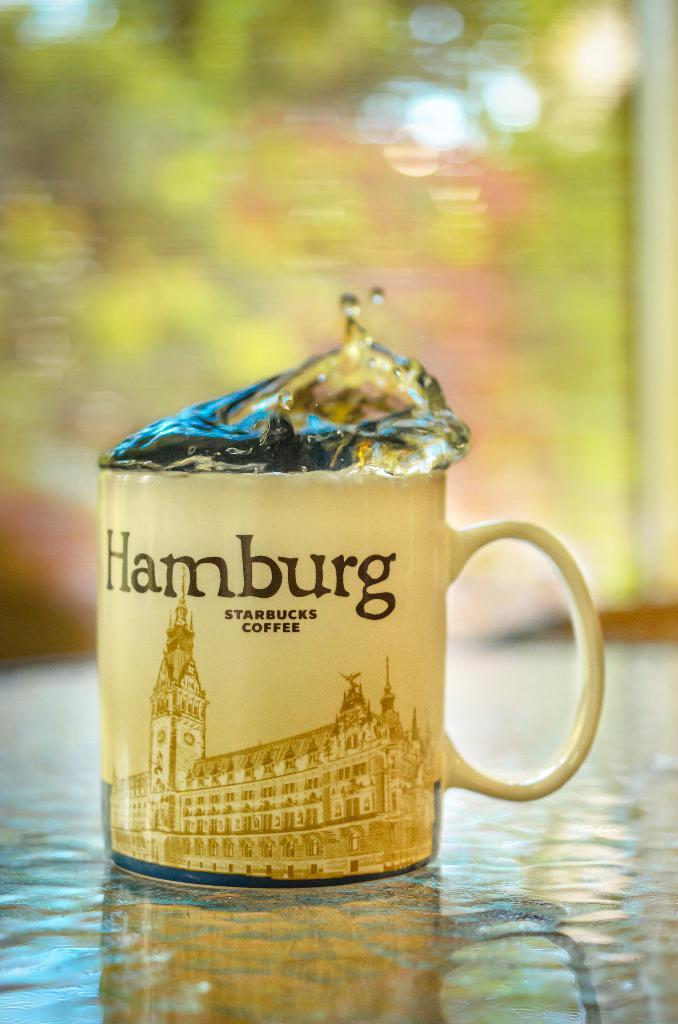<image>
Present a compact description of the photo's key features. A Starbucks coffee mug with "Hamburg" printed on the front. 